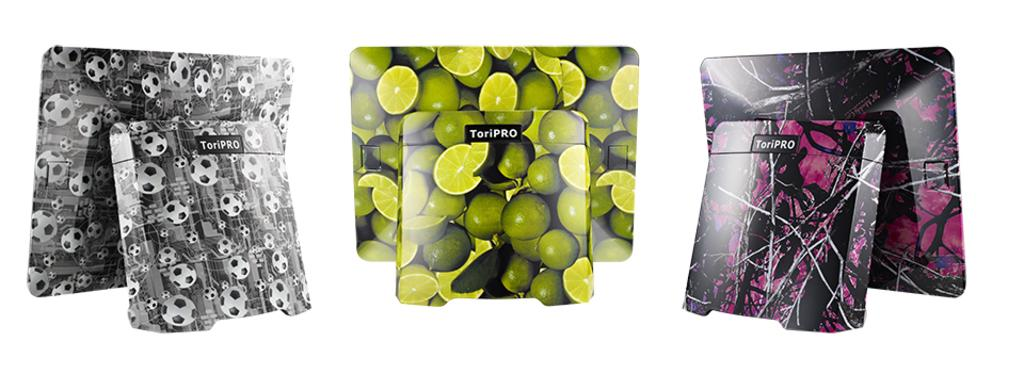What organization is responsible for managing the son's money in the image? There is no image or any related information provided, so it is impossible to determine the presence of an organization, a son, or any money in the context of an image. 